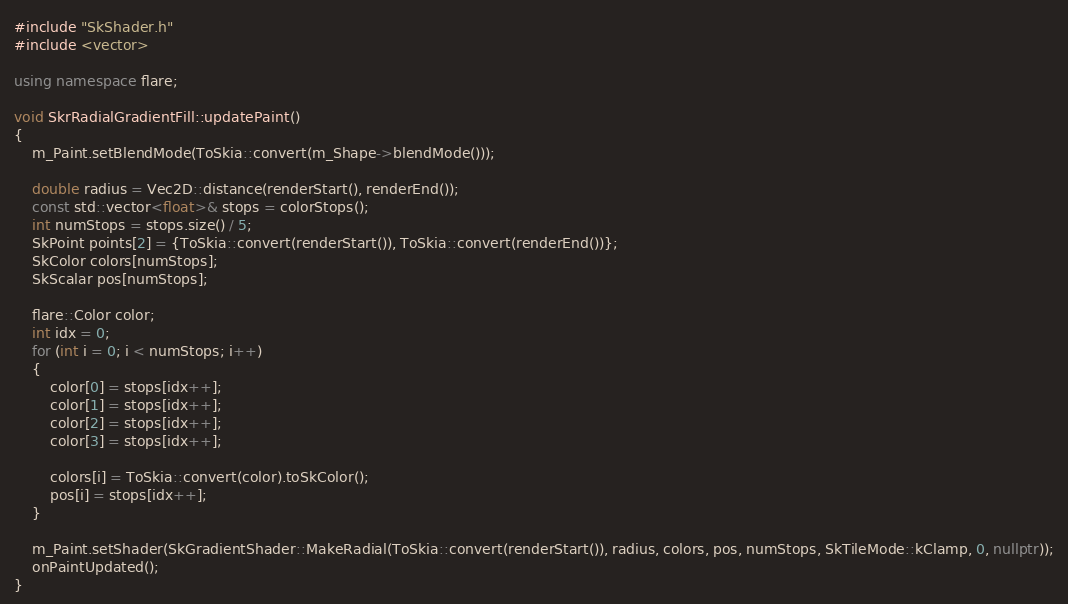Convert code to text. <code><loc_0><loc_0><loc_500><loc_500><_C++_>#include "SkShader.h"
#include <vector>

using namespace flare;

void SkrRadialGradientFill::updatePaint()
{
    m_Paint.setBlendMode(ToSkia::convert(m_Shape->blendMode()));

    double radius = Vec2D::distance(renderStart(), renderEnd());
	const std::vector<float>& stops = colorStops();
	int numStops = stops.size() / 5;
	SkPoint points[2] = {ToSkia::convert(renderStart()), ToSkia::convert(renderEnd())};
	SkColor colors[numStops];
	SkScalar pos[numStops];

	flare::Color color;
	int idx = 0;
	for (int i = 0; i < numStops; i++)
	{
		color[0] = stops[idx++];
		color[1] = stops[idx++];
		color[2] = stops[idx++];
		color[3] = stops[idx++];

		colors[i] = ToSkia::convert(color).toSkColor();
		pos[i] = stops[idx++];
	}
    
	m_Paint.setShader(SkGradientShader::MakeRadial(ToSkia::convert(renderStart()), radius, colors, pos, numStops, SkTileMode::kClamp, 0, nullptr));
	onPaintUpdated();
}</code> 